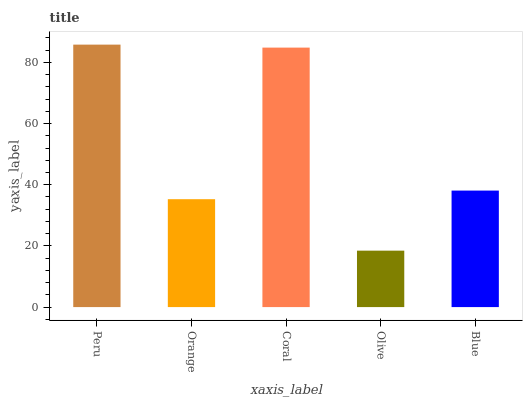Is Olive the minimum?
Answer yes or no. Yes. Is Peru the maximum?
Answer yes or no. Yes. Is Orange the minimum?
Answer yes or no. No. Is Orange the maximum?
Answer yes or no. No. Is Peru greater than Orange?
Answer yes or no. Yes. Is Orange less than Peru?
Answer yes or no. Yes. Is Orange greater than Peru?
Answer yes or no. No. Is Peru less than Orange?
Answer yes or no. No. Is Blue the high median?
Answer yes or no. Yes. Is Blue the low median?
Answer yes or no. Yes. Is Peru the high median?
Answer yes or no. No. Is Peru the low median?
Answer yes or no. No. 